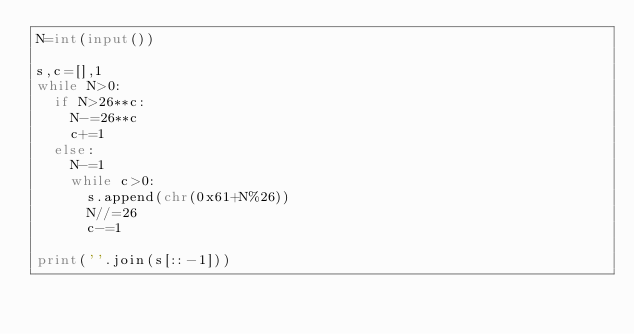Convert code to text. <code><loc_0><loc_0><loc_500><loc_500><_Python_>N=int(input())

s,c=[],1
while N>0:
  if N>26**c:
    N-=26**c
    c+=1
  else:
    N-=1
    while c>0:
      s.append(chr(0x61+N%26))
      N//=26
      c-=1

print(''.join(s[::-1]))
</code> 